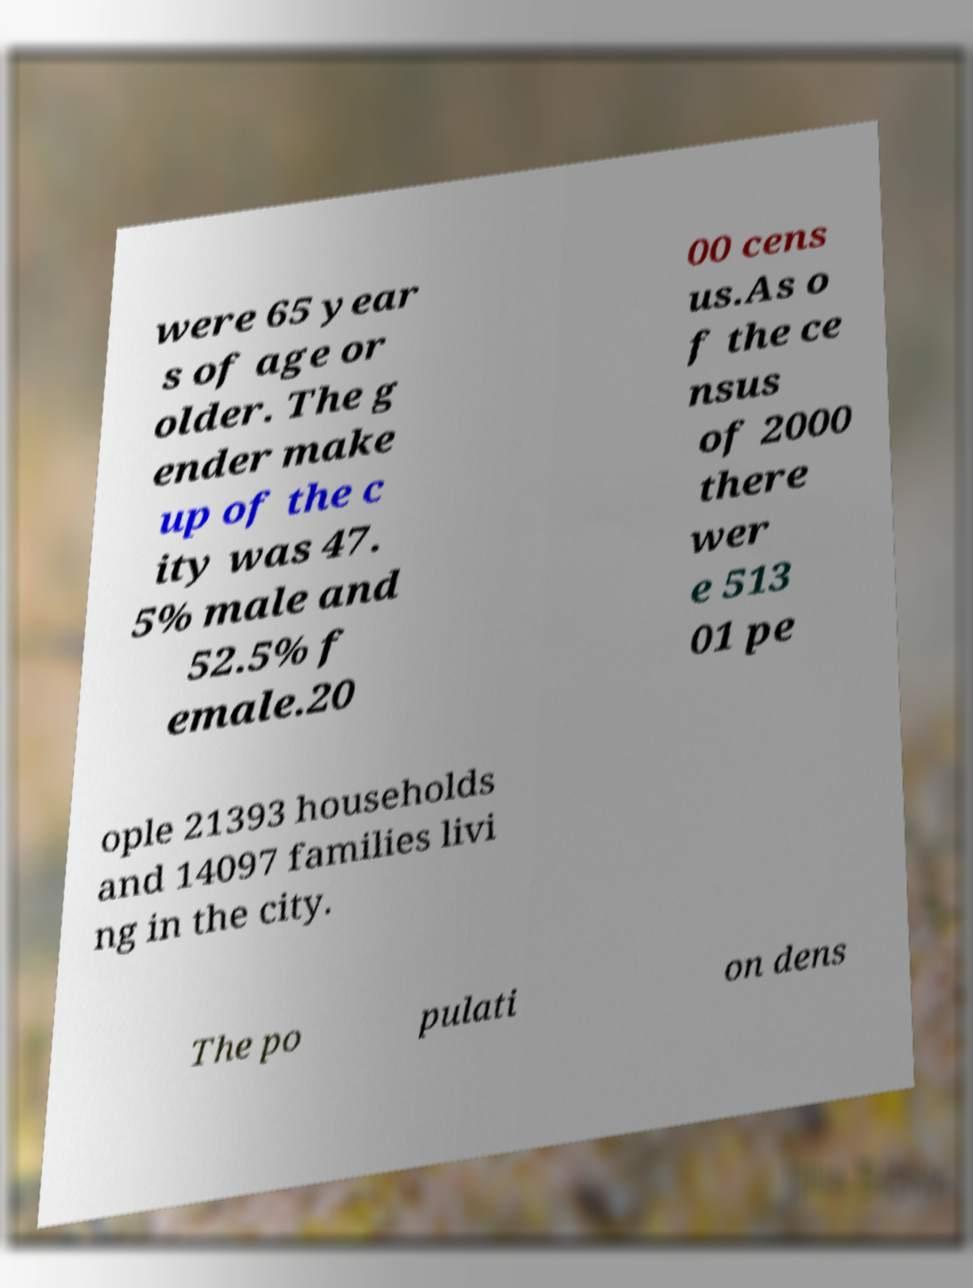For documentation purposes, I need the text within this image transcribed. Could you provide that? were 65 year s of age or older. The g ender make up of the c ity was 47. 5% male and 52.5% f emale.20 00 cens us.As o f the ce nsus of 2000 there wer e 513 01 pe ople 21393 households and 14097 families livi ng in the city. The po pulati on dens 